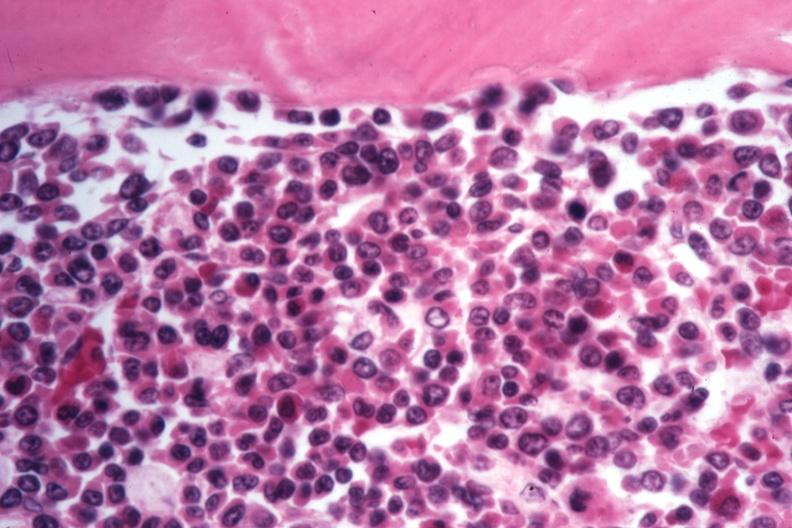what does this cells appear?
Answer the question using a single word or phrase. To be moving to blast crisis 